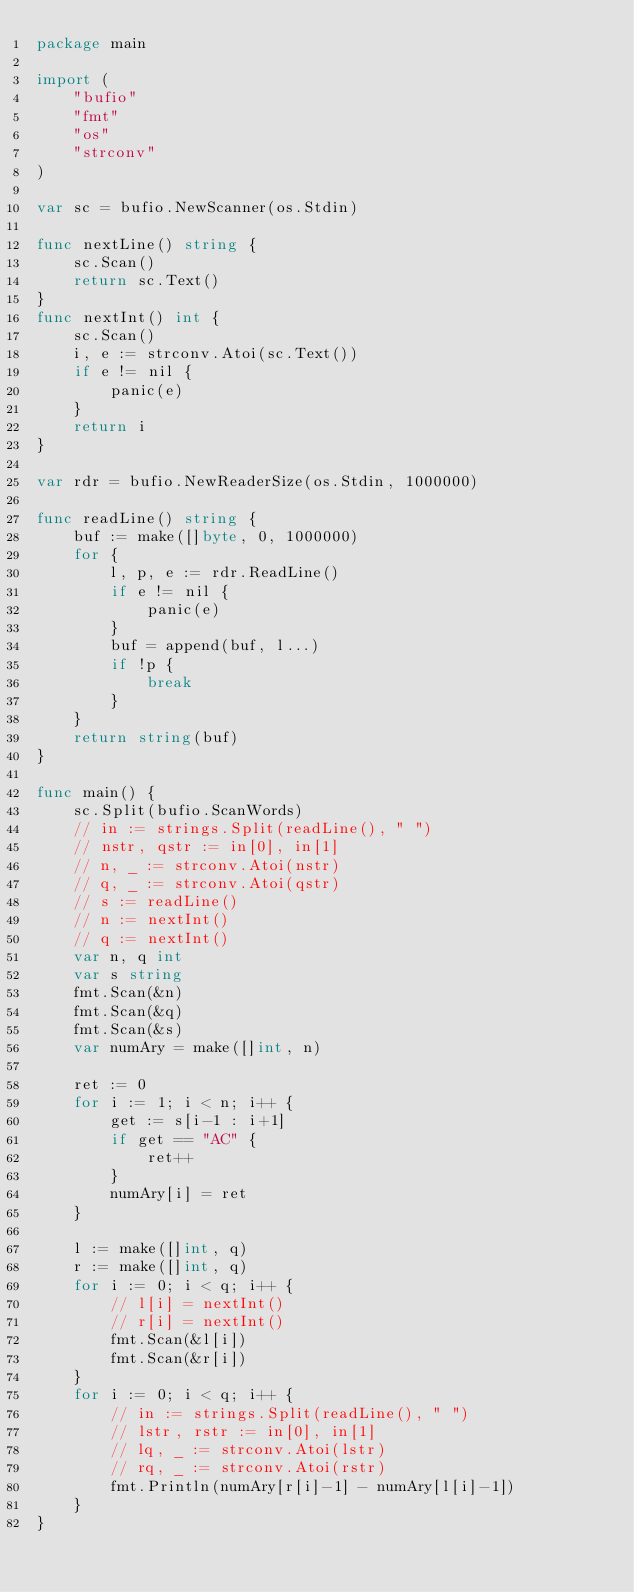<code> <loc_0><loc_0><loc_500><loc_500><_Go_>package main

import (
	"bufio"
	"fmt"
	"os"
	"strconv"
)

var sc = bufio.NewScanner(os.Stdin)

func nextLine() string {
	sc.Scan()
	return sc.Text()
}
func nextInt() int {
	sc.Scan()
	i, e := strconv.Atoi(sc.Text())
	if e != nil {
		panic(e)
	}
	return i
}

var rdr = bufio.NewReaderSize(os.Stdin, 1000000)

func readLine() string {
	buf := make([]byte, 0, 1000000)
	for {
		l, p, e := rdr.ReadLine()
		if e != nil {
			panic(e)
		}
		buf = append(buf, l...)
		if !p {
			break
		}
	}
	return string(buf)
}

func main() {
	sc.Split(bufio.ScanWords)
	// in := strings.Split(readLine(), " ")
	// nstr, qstr := in[0], in[1]
	// n, _ := strconv.Atoi(nstr)
	// q, _ := strconv.Atoi(qstr)
	// s := readLine()
	// n := nextInt()
	// q := nextInt()
	var n, q int
	var s string
	fmt.Scan(&n)
	fmt.Scan(&q)
	fmt.Scan(&s)
	var numAry = make([]int, n)

	ret := 0
	for i := 1; i < n; i++ {
		get := s[i-1 : i+1]
		if get == "AC" {
			ret++
		}
		numAry[i] = ret
	}

	l := make([]int, q)
	r := make([]int, q)
	for i := 0; i < q; i++ {
		// l[i] = nextInt()
		// r[i] = nextInt()
		fmt.Scan(&l[i])
		fmt.Scan(&r[i])
	}
	for i := 0; i < q; i++ {
		// in := strings.Split(readLine(), " ")
		// lstr, rstr := in[0], in[1]
		// lq, _ := strconv.Atoi(lstr)
		// rq, _ := strconv.Atoi(rstr)
		fmt.Println(numAry[r[i]-1] - numAry[l[i]-1])
	}
}
</code> 